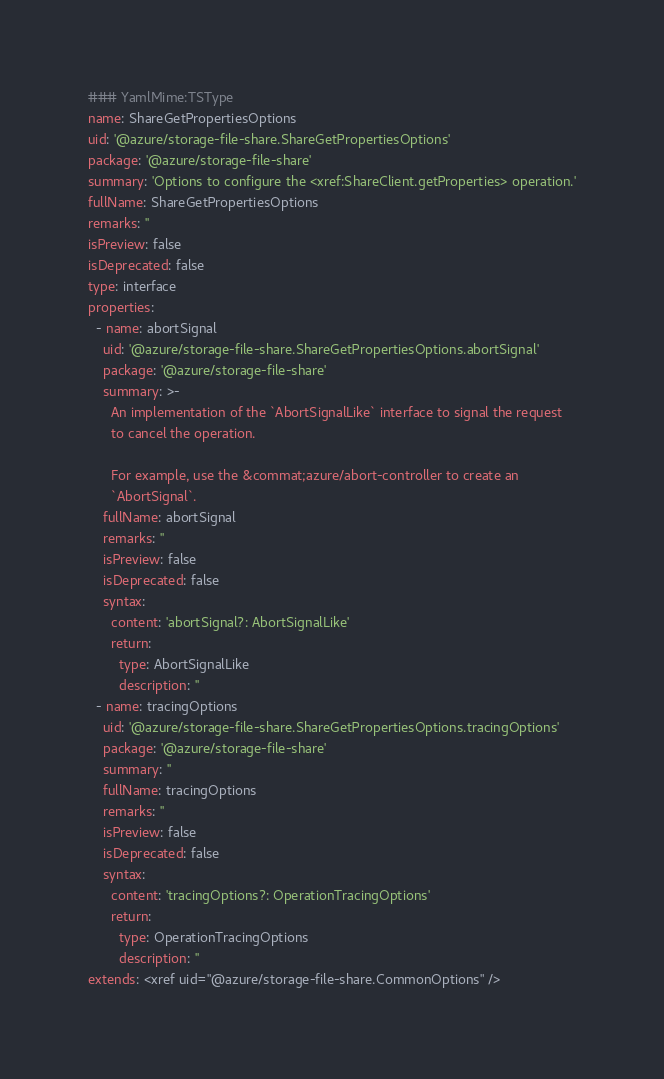Convert code to text. <code><loc_0><loc_0><loc_500><loc_500><_YAML_>### YamlMime:TSType
name: ShareGetPropertiesOptions
uid: '@azure/storage-file-share.ShareGetPropertiesOptions'
package: '@azure/storage-file-share'
summary: 'Options to configure the <xref:ShareClient.getProperties> operation.'
fullName: ShareGetPropertiesOptions
remarks: ''
isPreview: false
isDeprecated: false
type: interface
properties:
  - name: abortSignal
    uid: '@azure/storage-file-share.ShareGetPropertiesOptions.abortSignal'
    package: '@azure/storage-file-share'
    summary: >-
      An implementation of the `AbortSignalLike` interface to signal the request
      to cancel the operation.

      For example, use the &commat;azure/abort-controller to create an
      `AbortSignal`.
    fullName: abortSignal
    remarks: ''
    isPreview: false
    isDeprecated: false
    syntax:
      content: 'abortSignal?: AbortSignalLike'
      return:
        type: AbortSignalLike
        description: ''
  - name: tracingOptions
    uid: '@azure/storage-file-share.ShareGetPropertiesOptions.tracingOptions'
    package: '@azure/storage-file-share'
    summary: ''
    fullName: tracingOptions
    remarks: ''
    isPreview: false
    isDeprecated: false
    syntax:
      content: 'tracingOptions?: OperationTracingOptions'
      return:
        type: OperationTracingOptions
        description: ''
extends: <xref uid="@azure/storage-file-share.CommonOptions" />
</code> 